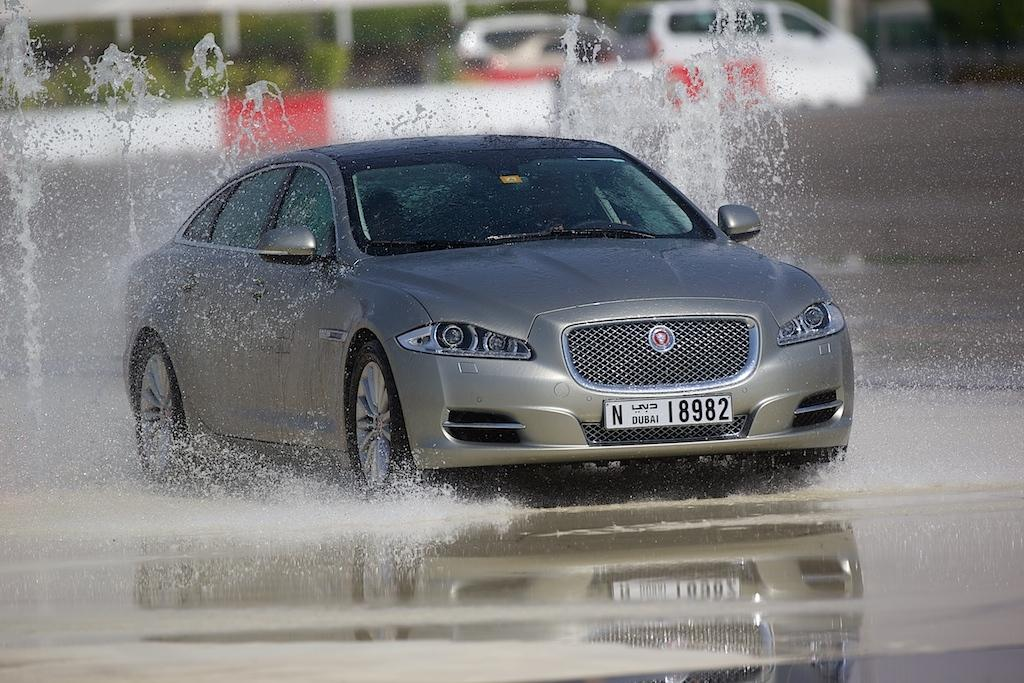What is on the ground in the image? There is a car and water on the ground in the image. What is located behind the car? There is a fence on the backside of the car. What can be seen in the background of the image? There are vehicles, poles, and plants visible in the background. What type of rhythm is the dog dancing to in the image? There is no dog present in the image, so it is not possible to determine the rhythm it might be dancing to. 